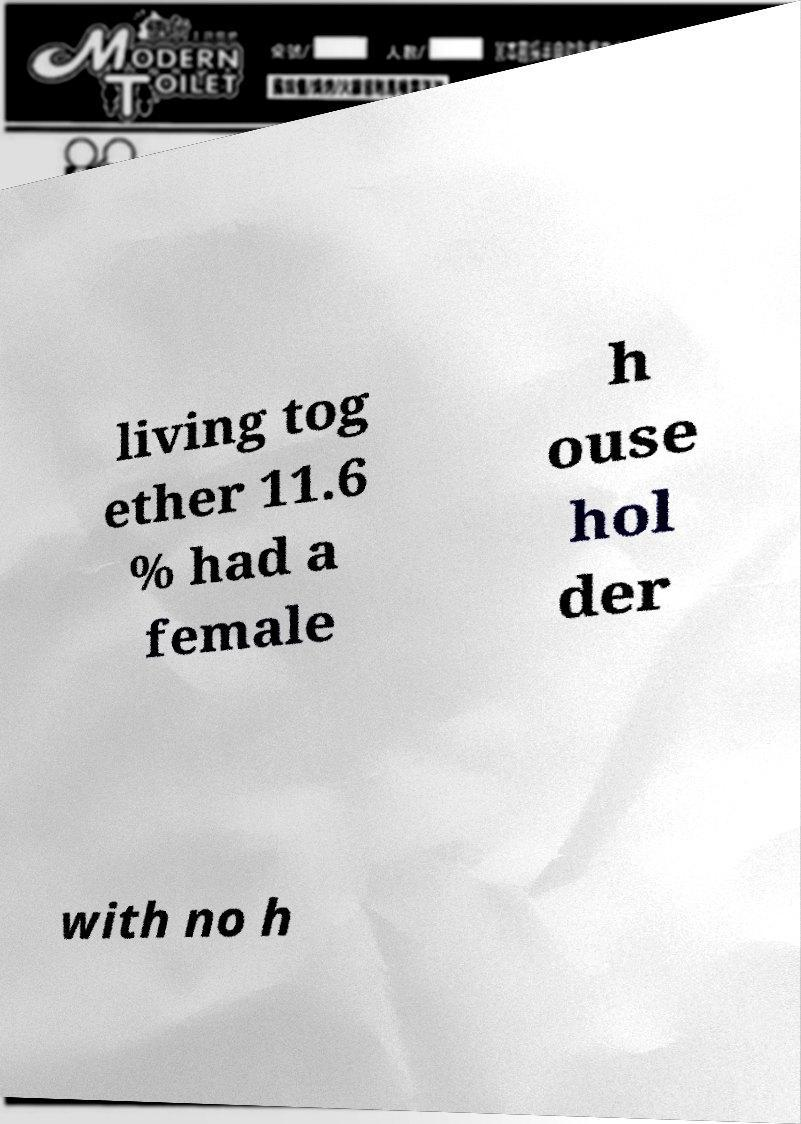Could you assist in decoding the text presented in this image and type it out clearly? living tog ether 11.6 % had a female h ouse hol der with no h 